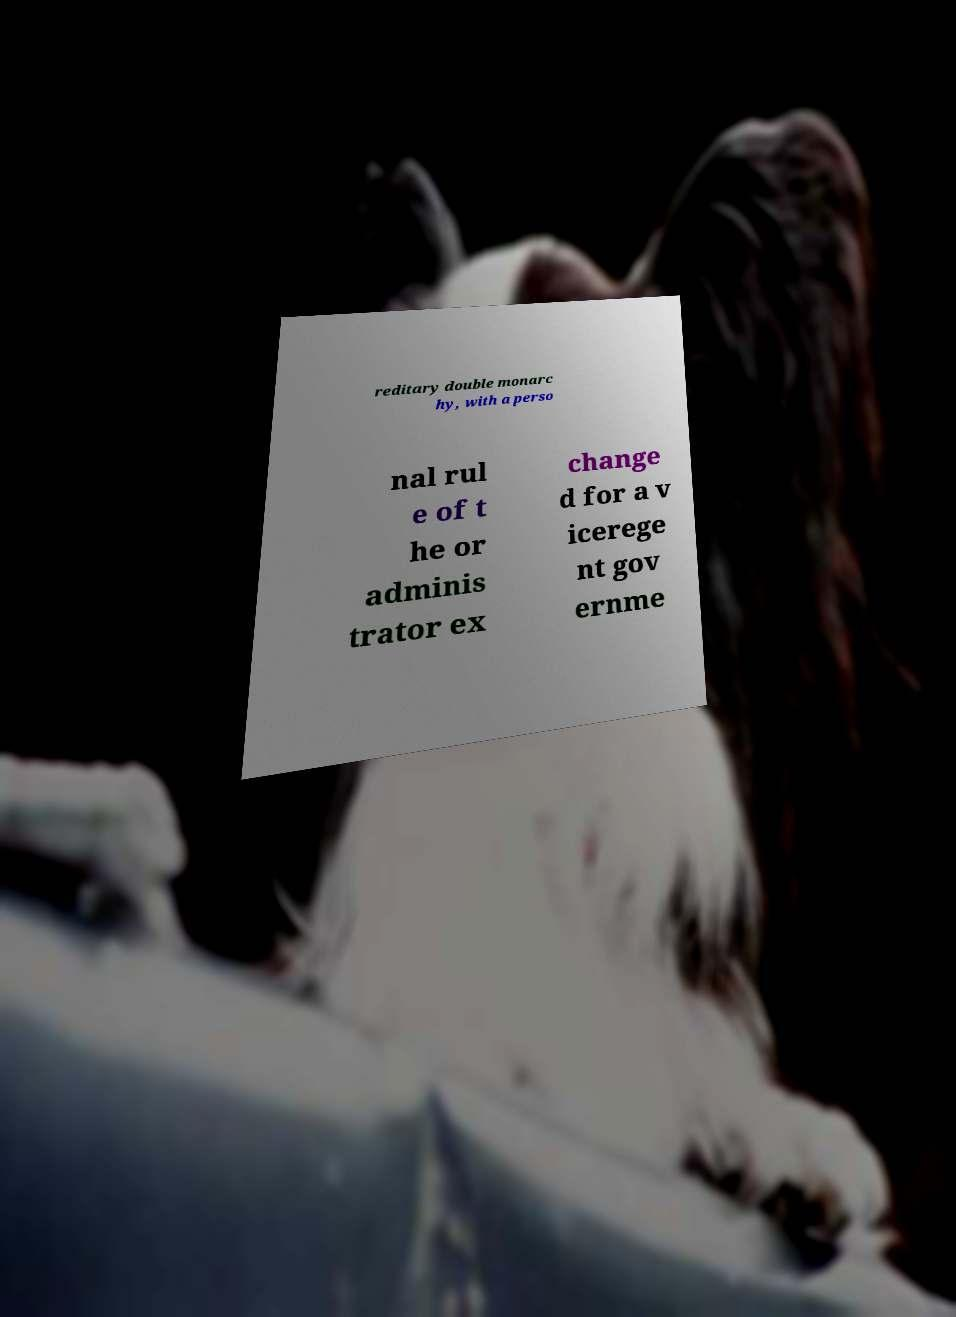Please identify and transcribe the text found in this image. reditary double monarc hy, with a perso nal rul e of t he or adminis trator ex change d for a v icerege nt gov ernme 